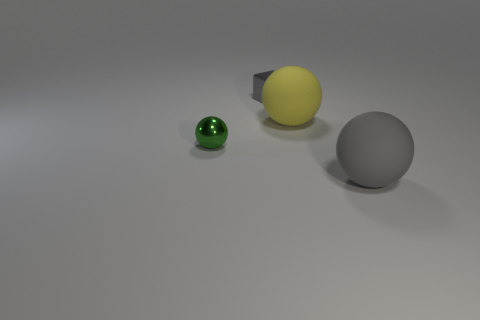Add 2 small green spheres. How many objects exist? 6 Subtract all spheres. How many objects are left? 1 Add 2 gray rubber things. How many gray rubber things are left? 3 Add 4 green balls. How many green balls exist? 5 Subtract 0 gray cylinders. How many objects are left? 4 Subtract all gray rubber objects. Subtract all big brown blocks. How many objects are left? 3 